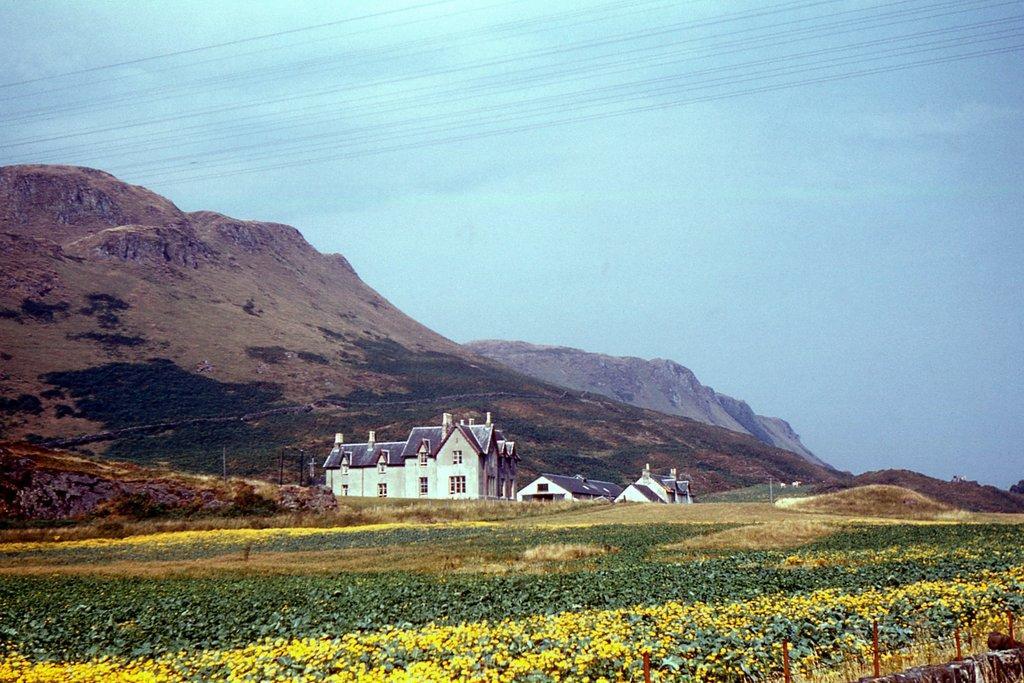Please provide a concise description of this image. In this image I see few houses over here and I see the plants which are of green and yellow in color. In the background I see the mountains and I see the blue sky and I can also see the wires over here. 